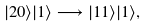<formula> <loc_0><loc_0><loc_500><loc_500>| 2 0 \rangle | 1 \rangle \longrightarrow | 1 1 \rangle | 1 \rangle ,</formula> 